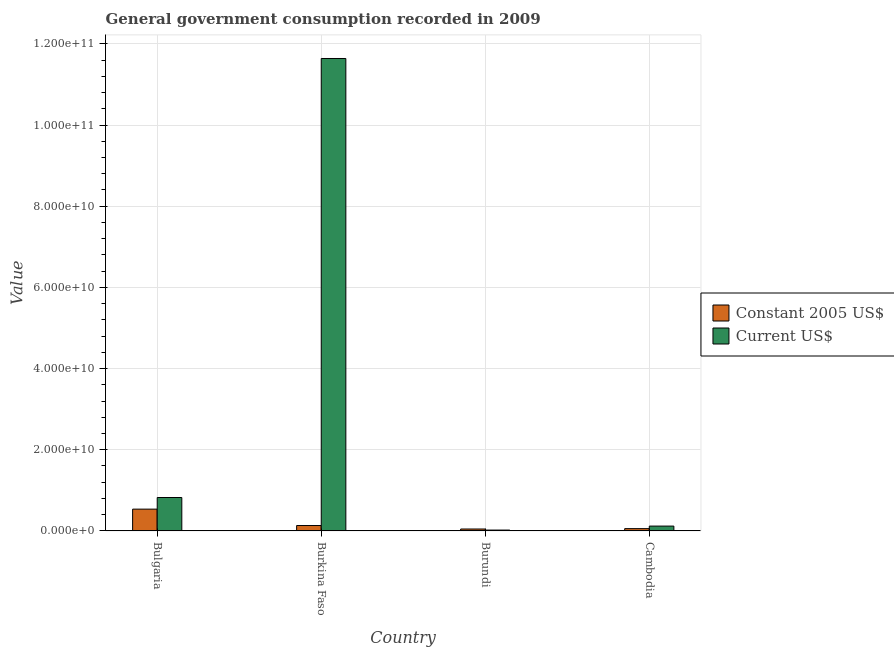How many groups of bars are there?
Provide a short and direct response. 4. Are the number of bars per tick equal to the number of legend labels?
Give a very brief answer. Yes. What is the label of the 3rd group of bars from the left?
Offer a terse response. Burundi. What is the value consumed in constant 2005 us$ in Burundi?
Make the answer very short. 4.75e+08. Across all countries, what is the maximum value consumed in constant 2005 us$?
Your answer should be compact. 5.37e+09. Across all countries, what is the minimum value consumed in constant 2005 us$?
Give a very brief answer. 4.75e+08. In which country was the value consumed in current us$ maximum?
Keep it short and to the point. Burkina Faso. In which country was the value consumed in current us$ minimum?
Provide a short and direct response. Burundi. What is the total value consumed in current us$ in the graph?
Your answer should be very brief. 1.26e+11. What is the difference between the value consumed in current us$ in Bulgaria and that in Cambodia?
Make the answer very short. 7.04e+09. What is the difference between the value consumed in constant 2005 us$ in Bulgaria and the value consumed in current us$ in Burundi?
Offer a very short reply. 5.16e+09. What is the average value consumed in constant 2005 us$ per country?
Your answer should be very brief. 1.94e+09. What is the difference between the value consumed in constant 2005 us$ and value consumed in current us$ in Burkina Faso?
Provide a succinct answer. -1.15e+11. In how many countries, is the value consumed in current us$ greater than 8000000000 ?
Your response must be concise. 2. What is the ratio of the value consumed in constant 2005 us$ in Burkina Faso to that in Cambodia?
Provide a succinct answer. 2.35. Is the difference between the value consumed in current us$ in Burkina Faso and Cambodia greater than the difference between the value consumed in constant 2005 us$ in Burkina Faso and Cambodia?
Your answer should be compact. Yes. What is the difference between the highest and the second highest value consumed in constant 2005 us$?
Offer a very short reply. 4.04e+09. What is the difference between the highest and the lowest value consumed in current us$?
Your answer should be very brief. 1.16e+11. What does the 1st bar from the left in Burkina Faso represents?
Your response must be concise. Constant 2005 US$. What does the 1st bar from the right in Burkina Faso represents?
Provide a succinct answer. Current US$. Are all the bars in the graph horizontal?
Provide a short and direct response. No. How many countries are there in the graph?
Your answer should be very brief. 4. Does the graph contain any zero values?
Offer a very short reply. No. Does the graph contain grids?
Your answer should be compact. Yes. What is the title of the graph?
Give a very brief answer. General government consumption recorded in 2009. Does "Fixed telephone" appear as one of the legend labels in the graph?
Keep it short and to the point. No. What is the label or title of the X-axis?
Offer a terse response. Country. What is the label or title of the Y-axis?
Your response must be concise. Value. What is the Value of Constant 2005 US$ in Bulgaria?
Offer a very short reply. 5.37e+09. What is the Value in Current US$ in Bulgaria?
Give a very brief answer. 8.24e+09. What is the Value of Constant 2005 US$ in Burkina Faso?
Your response must be concise. 1.33e+09. What is the Value in Current US$ in Burkina Faso?
Provide a short and direct response. 1.16e+11. What is the Value in Constant 2005 US$ in Burundi?
Your response must be concise. 4.75e+08. What is the Value of Current US$ in Burundi?
Provide a short and direct response. 2.13e+08. What is the Value of Constant 2005 US$ in Cambodia?
Your answer should be very brief. 5.67e+08. What is the Value in Current US$ in Cambodia?
Make the answer very short. 1.20e+09. Across all countries, what is the maximum Value in Constant 2005 US$?
Ensure brevity in your answer.  5.37e+09. Across all countries, what is the maximum Value of Current US$?
Ensure brevity in your answer.  1.16e+11. Across all countries, what is the minimum Value of Constant 2005 US$?
Make the answer very short. 4.75e+08. Across all countries, what is the minimum Value in Current US$?
Ensure brevity in your answer.  2.13e+08. What is the total Value of Constant 2005 US$ in the graph?
Your response must be concise. 7.75e+09. What is the total Value in Current US$ in the graph?
Your answer should be compact. 1.26e+11. What is the difference between the Value in Constant 2005 US$ in Bulgaria and that in Burkina Faso?
Your answer should be compact. 4.04e+09. What is the difference between the Value of Current US$ in Bulgaria and that in Burkina Faso?
Make the answer very short. -1.08e+11. What is the difference between the Value of Constant 2005 US$ in Bulgaria and that in Burundi?
Your answer should be very brief. 4.90e+09. What is the difference between the Value in Current US$ in Bulgaria and that in Burundi?
Ensure brevity in your answer.  8.02e+09. What is the difference between the Value in Constant 2005 US$ in Bulgaria and that in Cambodia?
Keep it short and to the point. 4.80e+09. What is the difference between the Value in Current US$ in Bulgaria and that in Cambodia?
Make the answer very short. 7.04e+09. What is the difference between the Value of Constant 2005 US$ in Burkina Faso and that in Burundi?
Give a very brief answer. 8.58e+08. What is the difference between the Value of Current US$ in Burkina Faso and that in Burundi?
Provide a short and direct response. 1.16e+11. What is the difference between the Value in Constant 2005 US$ in Burkina Faso and that in Cambodia?
Provide a succinct answer. 7.66e+08. What is the difference between the Value in Current US$ in Burkina Faso and that in Cambodia?
Make the answer very short. 1.15e+11. What is the difference between the Value in Constant 2005 US$ in Burundi and that in Cambodia?
Offer a terse response. -9.20e+07. What is the difference between the Value in Current US$ in Burundi and that in Cambodia?
Keep it short and to the point. -9.85e+08. What is the difference between the Value in Constant 2005 US$ in Bulgaria and the Value in Current US$ in Burkina Faso?
Your answer should be compact. -1.11e+11. What is the difference between the Value of Constant 2005 US$ in Bulgaria and the Value of Current US$ in Burundi?
Give a very brief answer. 5.16e+09. What is the difference between the Value in Constant 2005 US$ in Bulgaria and the Value in Current US$ in Cambodia?
Give a very brief answer. 4.17e+09. What is the difference between the Value in Constant 2005 US$ in Burkina Faso and the Value in Current US$ in Burundi?
Give a very brief answer. 1.12e+09. What is the difference between the Value of Constant 2005 US$ in Burkina Faso and the Value of Current US$ in Cambodia?
Provide a succinct answer. 1.35e+08. What is the difference between the Value of Constant 2005 US$ in Burundi and the Value of Current US$ in Cambodia?
Ensure brevity in your answer.  -7.23e+08. What is the average Value of Constant 2005 US$ per country?
Provide a succinct answer. 1.94e+09. What is the average Value of Current US$ per country?
Offer a terse response. 3.15e+1. What is the difference between the Value in Constant 2005 US$ and Value in Current US$ in Bulgaria?
Keep it short and to the point. -2.86e+09. What is the difference between the Value of Constant 2005 US$ and Value of Current US$ in Burkina Faso?
Offer a terse response. -1.15e+11. What is the difference between the Value in Constant 2005 US$ and Value in Current US$ in Burundi?
Keep it short and to the point. 2.62e+08. What is the difference between the Value in Constant 2005 US$ and Value in Current US$ in Cambodia?
Provide a short and direct response. -6.31e+08. What is the ratio of the Value of Constant 2005 US$ in Bulgaria to that in Burkina Faso?
Make the answer very short. 4.03. What is the ratio of the Value of Current US$ in Bulgaria to that in Burkina Faso?
Offer a very short reply. 0.07. What is the ratio of the Value of Constant 2005 US$ in Bulgaria to that in Burundi?
Your answer should be very brief. 11.32. What is the ratio of the Value in Current US$ in Bulgaria to that in Burundi?
Provide a short and direct response. 38.73. What is the ratio of the Value of Constant 2005 US$ in Bulgaria to that in Cambodia?
Your response must be concise. 9.48. What is the ratio of the Value in Current US$ in Bulgaria to that in Cambodia?
Offer a terse response. 6.88. What is the ratio of the Value of Constant 2005 US$ in Burkina Faso to that in Burundi?
Keep it short and to the point. 2.81. What is the ratio of the Value in Current US$ in Burkina Faso to that in Burundi?
Keep it short and to the point. 547.41. What is the ratio of the Value in Constant 2005 US$ in Burkina Faso to that in Cambodia?
Keep it short and to the point. 2.35. What is the ratio of the Value of Current US$ in Burkina Faso to that in Cambodia?
Provide a succinct answer. 97.22. What is the ratio of the Value in Constant 2005 US$ in Burundi to that in Cambodia?
Ensure brevity in your answer.  0.84. What is the ratio of the Value of Current US$ in Burundi to that in Cambodia?
Your answer should be very brief. 0.18. What is the difference between the highest and the second highest Value of Constant 2005 US$?
Keep it short and to the point. 4.04e+09. What is the difference between the highest and the second highest Value of Current US$?
Provide a succinct answer. 1.08e+11. What is the difference between the highest and the lowest Value of Constant 2005 US$?
Make the answer very short. 4.90e+09. What is the difference between the highest and the lowest Value in Current US$?
Your response must be concise. 1.16e+11. 